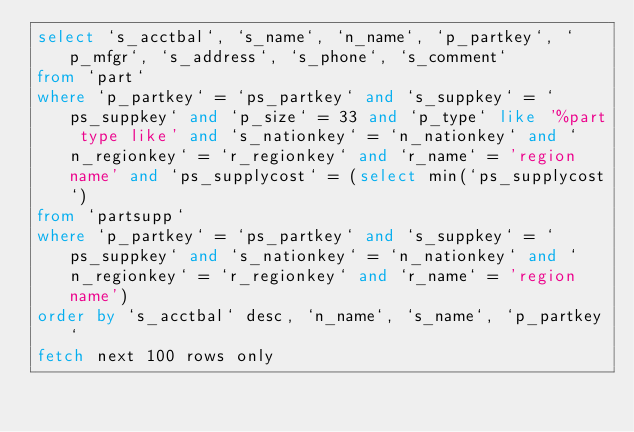Convert code to text. <code><loc_0><loc_0><loc_500><loc_500><_SQL_>select `s_acctbal`, `s_name`, `n_name`, `p_partkey`, `p_mfgr`, `s_address`, `s_phone`, `s_comment`
from `part`
where `p_partkey` = `ps_partkey` and `s_suppkey` = `ps_suppkey` and `p_size` = 33 and `p_type` like '%part type like' and `s_nationkey` = `n_nationkey` and `n_regionkey` = `r_regionkey` and `r_name` = 'region name' and `ps_supplycost` = (select min(`ps_supplycost`)
from `partsupp`
where `p_partkey` = `ps_partkey` and `s_suppkey` = `ps_suppkey` and `s_nationkey` = `n_nationkey` and `n_regionkey` = `r_regionkey` and `r_name` = 'region name')
order by `s_acctbal` desc, `n_name`, `s_name`, `p_partkey`
fetch next 100 rows only</code> 